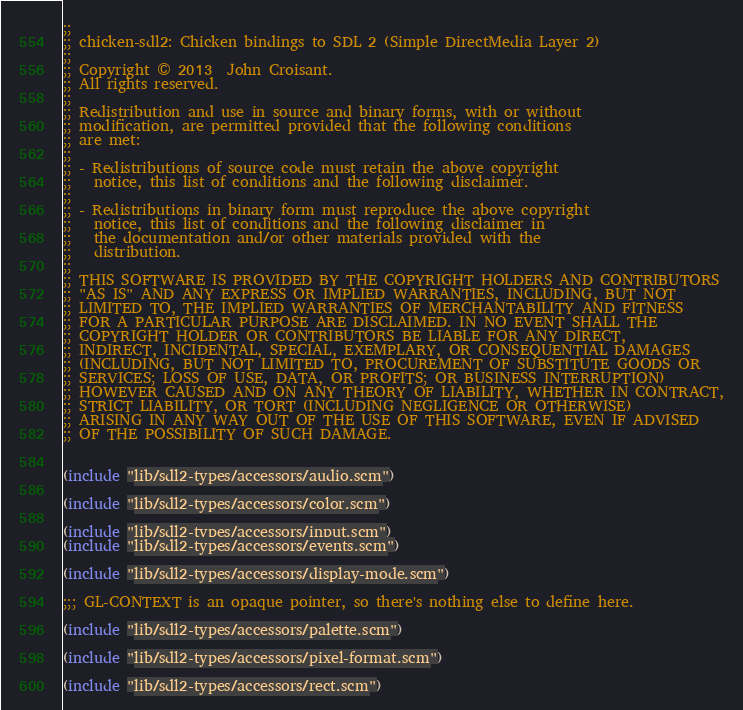Convert code to text. <code><loc_0><loc_0><loc_500><loc_500><_Scheme_>;;
;; chicken-sdl2: Chicken bindings to SDL 2 (Simple DirectMedia Layer 2)
;;
;; Copyright © 2013  John Croisant.
;; All rights reserved.
;;
;; Redistribution and use in source and binary forms, with or without
;; modification, are permitted provided that the following conditions
;; are met:
;;
;; - Redistributions of source code must retain the above copyright
;;   notice, this list of conditions and the following disclaimer.
;;
;; - Redistributions in binary form must reproduce the above copyright
;;   notice, this list of conditions and the following disclaimer in
;;   the documentation and/or other materials provided with the
;;   distribution.
;;
;; THIS SOFTWARE IS PROVIDED BY THE COPYRIGHT HOLDERS AND CONTRIBUTORS
;; "AS IS" AND ANY EXPRESS OR IMPLIED WARRANTIES, INCLUDING, BUT NOT
;; LIMITED TO, THE IMPLIED WARRANTIES OF MERCHANTABILITY AND FITNESS
;; FOR A PARTICULAR PURPOSE ARE DISCLAIMED. IN NO EVENT SHALL THE
;; COPYRIGHT HOLDER OR CONTRIBUTORS BE LIABLE FOR ANY DIRECT,
;; INDIRECT, INCIDENTAL, SPECIAL, EXEMPLARY, OR CONSEQUENTIAL DAMAGES
;; (INCLUDING, BUT NOT LIMITED TO, PROCUREMENT OF SUBSTITUTE GOODS OR
;; SERVICES; LOSS OF USE, DATA, OR PROFITS; OR BUSINESS INTERRUPTION)
;; HOWEVER CAUSED AND ON ANY THEORY OF LIABILITY, WHETHER IN CONTRACT,
;; STRICT LIABILITY, OR TORT (INCLUDING NEGLIGENCE OR OTHERWISE)
;; ARISING IN ANY WAY OUT OF THE USE OF THIS SOFTWARE, EVEN IF ADVISED
;; OF THE POSSIBILITY OF SUCH DAMAGE.


(include "lib/sdl2-types/accessors/audio.scm")

(include "lib/sdl2-types/accessors/color.scm")

(include "lib/sdl2-types/accessors/input.scm")
(include "lib/sdl2-types/accessors/events.scm")

(include "lib/sdl2-types/accessors/display-mode.scm")

;;; GL-CONTEXT is an opaque pointer, so there's nothing else to define here.

(include "lib/sdl2-types/accessors/palette.scm")

(include "lib/sdl2-types/accessors/pixel-format.scm")

(include "lib/sdl2-types/accessors/rect.scm")
</code> 